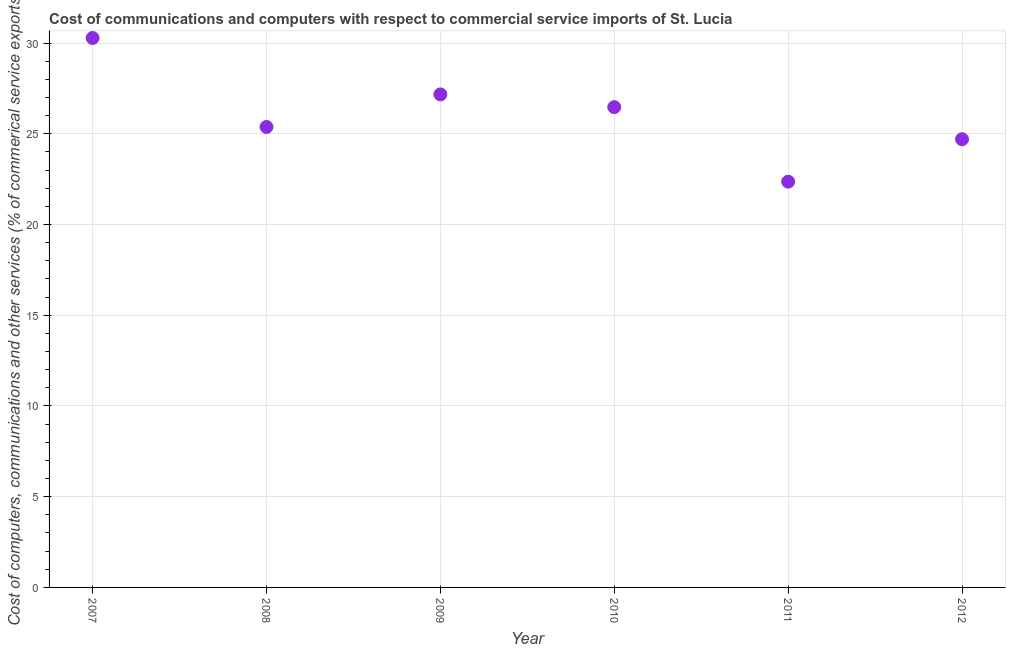What is the  computer and other services in 2012?
Offer a very short reply. 24.7. Across all years, what is the maximum cost of communications?
Your answer should be very brief. 30.28. Across all years, what is the minimum cost of communications?
Offer a terse response. 22.36. In which year was the  computer and other services maximum?
Provide a short and direct response. 2007. In which year was the cost of communications minimum?
Provide a short and direct response. 2011. What is the sum of the cost of communications?
Provide a short and direct response. 156.36. What is the difference between the cost of communications in 2008 and 2010?
Your answer should be very brief. -1.09. What is the average cost of communications per year?
Provide a succinct answer. 26.06. What is the median  computer and other services?
Your answer should be compact. 25.92. Do a majority of the years between 2012 and 2007 (inclusive) have  computer and other services greater than 13 %?
Ensure brevity in your answer.  Yes. What is the ratio of the cost of communications in 2008 to that in 2011?
Keep it short and to the point. 1.13. Is the difference between the cost of communications in 2011 and 2012 greater than the difference between any two years?
Offer a very short reply. No. What is the difference between the highest and the second highest cost of communications?
Give a very brief answer. 3.11. What is the difference between the highest and the lowest cost of communications?
Offer a very short reply. 7.92. Does the  computer and other services monotonically increase over the years?
Your answer should be compact. No. What is the difference between two consecutive major ticks on the Y-axis?
Your response must be concise. 5. Does the graph contain any zero values?
Offer a terse response. No. What is the title of the graph?
Keep it short and to the point. Cost of communications and computers with respect to commercial service imports of St. Lucia. What is the label or title of the Y-axis?
Offer a very short reply. Cost of computers, communications and other services (% of commerical service exports). What is the Cost of computers, communications and other services (% of commerical service exports) in 2007?
Give a very brief answer. 30.28. What is the Cost of computers, communications and other services (% of commerical service exports) in 2008?
Your answer should be very brief. 25.38. What is the Cost of computers, communications and other services (% of commerical service exports) in 2009?
Your answer should be very brief. 27.17. What is the Cost of computers, communications and other services (% of commerical service exports) in 2010?
Give a very brief answer. 26.47. What is the Cost of computers, communications and other services (% of commerical service exports) in 2011?
Offer a terse response. 22.36. What is the Cost of computers, communications and other services (% of commerical service exports) in 2012?
Offer a terse response. 24.7. What is the difference between the Cost of computers, communications and other services (% of commerical service exports) in 2007 and 2008?
Your response must be concise. 4.9. What is the difference between the Cost of computers, communications and other services (% of commerical service exports) in 2007 and 2009?
Offer a very short reply. 3.11. What is the difference between the Cost of computers, communications and other services (% of commerical service exports) in 2007 and 2010?
Ensure brevity in your answer.  3.81. What is the difference between the Cost of computers, communications and other services (% of commerical service exports) in 2007 and 2011?
Offer a very short reply. 7.92. What is the difference between the Cost of computers, communications and other services (% of commerical service exports) in 2007 and 2012?
Your response must be concise. 5.58. What is the difference between the Cost of computers, communications and other services (% of commerical service exports) in 2008 and 2009?
Ensure brevity in your answer.  -1.79. What is the difference between the Cost of computers, communications and other services (% of commerical service exports) in 2008 and 2010?
Keep it short and to the point. -1.09. What is the difference between the Cost of computers, communications and other services (% of commerical service exports) in 2008 and 2011?
Your answer should be compact. 3.01. What is the difference between the Cost of computers, communications and other services (% of commerical service exports) in 2008 and 2012?
Your answer should be compact. 0.68. What is the difference between the Cost of computers, communications and other services (% of commerical service exports) in 2009 and 2010?
Make the answer very short. 0.7. What is the difference between the Cost of computers, communications and other services (% of commerical service exports) in 2009 and 2011?
Offer a terse response. 4.81. What is the difference between the Cost of computers, communications and other services (% of commerical service exports) in 2009 and 2012?
Provide a short and direct response. 2.47. What is the difference between the Cost of computers, communications and other services (% of commerical service exports) in 2010 and 2011?
Ensure brevity in your answer.  4.11. What is the difference between the Cost of computers, communications and other services (% of commerical service exports) in 2010 and 2012?
Provide a short and direct response. 1.77. What is the difference between the Cost of computers, communications and other services (% of commerical service exports) in 2011 and 2012?
Keep it short and to the point. -2.34. What is the ratio of the Cost of computers, communications and other services (% of commerical service exports) in 2007 to that in 2008?
Keep it short and to the point. 1.19. What is the ratio of the Cost of computers, communications and other services (% of commerical service exports) in 2007 to that in 2009?
Your answer should be compact. 1.11. What is the ratio of the Cost of computers, communications and other services (% of commerical service exports) in 2007 to that in 2010?
Make the answer very short. 1.14. What is the ratio of the Cost of computers, communications and other services (% of commerical service exports) in 2007 to that in 2011?
Provide a succinct answer. 1.35. What is the ratio of the Cost of computers, communications and other services (% of commerical service exports) in 2007 to that in 2012?
Make the answer very short. 1.23. What is the ratio of the Cost of computers, communications and other services (% of commerical service exports) in 2008 to that in 2009?
Offer a terse response. 0.93. What is the ratio of the Cost of computers, communications and other services (% of commerical service exports) in 2008 to that in 2011?
Keep it short and to the point. 1.14. What is the ratio of the Cost of computers, communications and other services (% of commerical service exports) in 2009 to that in 2010?
Keep it short and to the point. 1.03. What is the ratio of the Cost of computers, communications and other services (% of commerical service exports) in 2009 to that in 2011?
Provide a short and direct response. 1.22. What is the ratio of the Cost of computers, communications and other services (% of commerical service exports) in 2009 to that in 2012?
Keep it short and to the point. 1.1. What is the ratio of the Cost of computers, communications and other services (% of commerical service exports) in 2010 to that in 2011?
Give a very brief answer. 1.18. What is the ratio of the Cost of computers, communications and other services (% of commerical service exports) in 2010 to that in 2012?
Provide a succinct answer. 1.07. What is the ratio of the Cost of computers, communications and other services (% of commerical service exports) in 2011 to that in 2012?
Ensure brevity in your answer.  0.91. 